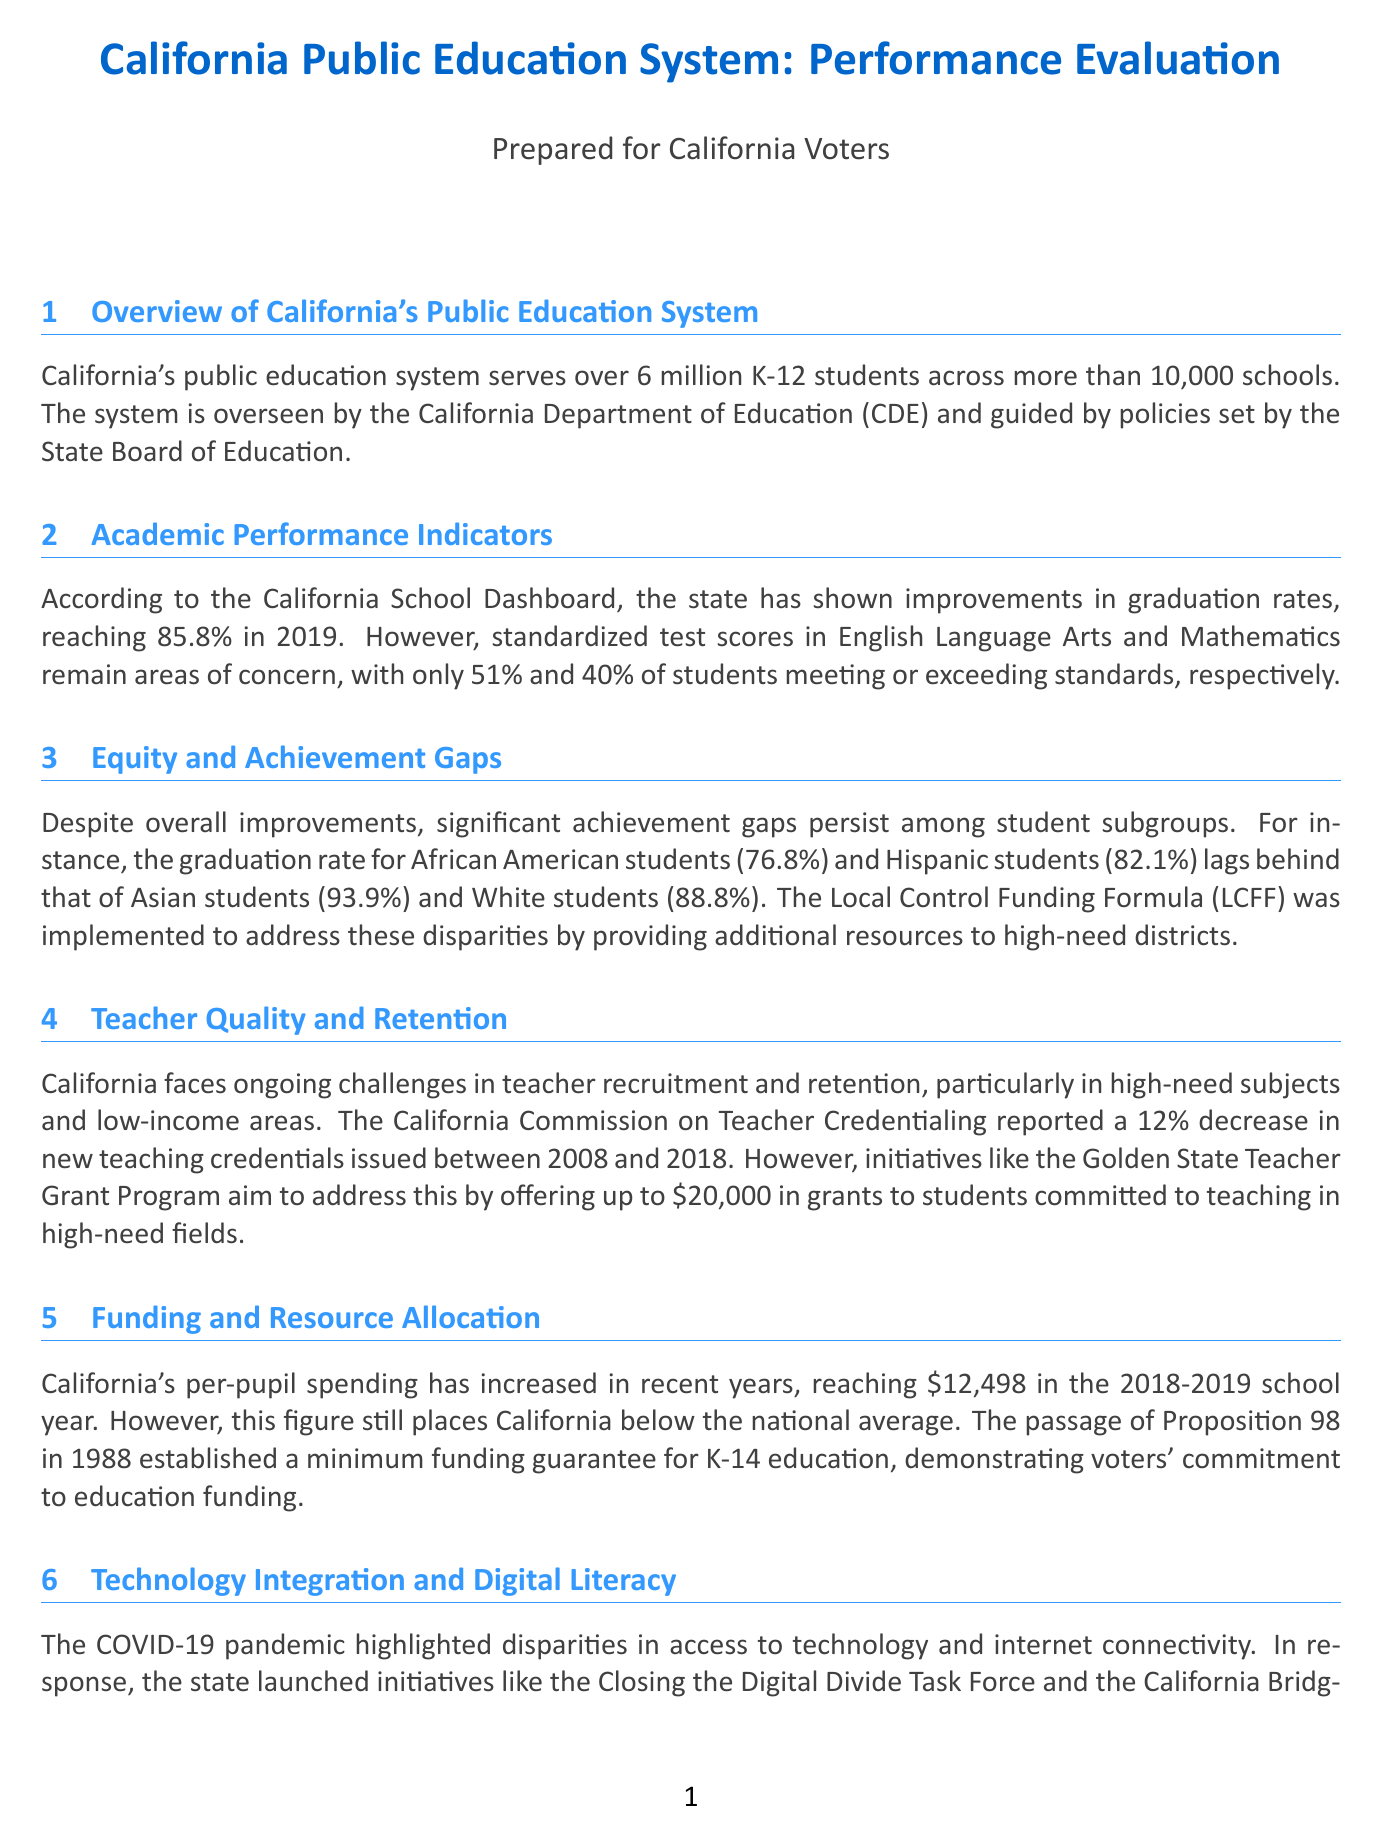What is the graduation rate for California in 2019? The graduation rate for California reached 85.8% in 2019, as stated in the Academic Performance Indicators section.
Answer: 85.8% What percentage of students met or exceeded standards in Mathematics? According to the Academic Performance Indicators section, only 40% of students met or exceeded standards in Mathematics.
Answer: 40% What gap exists between African American and Asian student graduation rates? The graduation rate for African American students is 76.8%, while that of Asian students is 93.9%, indicating a gap of 17.1%.
Answer: 17.1% What program aims to improve teacher recruitment in California? The Golden State Teacher Grant Program is mentioned as an initiative to address teacher recruitment challenges.
Answer: Golden State Teacher Grant Program What is California's per-pupil spending for the 2018-2019 school year? California's per-pupil spending reached $12,498 in the 2018-2019 school year, as indicated in the Funding and Resource Allocation section.
Answer: $12,498 How many students with disabilities does California serve? California serves over 795,000 students with disabilities, representing about 13% of the total K-12 population, according to the Special Education Services section.
Answer: 795,000 What initiative focuses on closing the digital divide in California? The Closing the Digital Divide Task Force is one initiative launched in response to technology access disparities.
Answer: Closing the Digital Divide Task Force What percentage of high school students participated in CTE courses in 2019? The document states that 45% of high school students participated in Career and Technical Education (CTE) courses in 2019.
Answer: 45% 